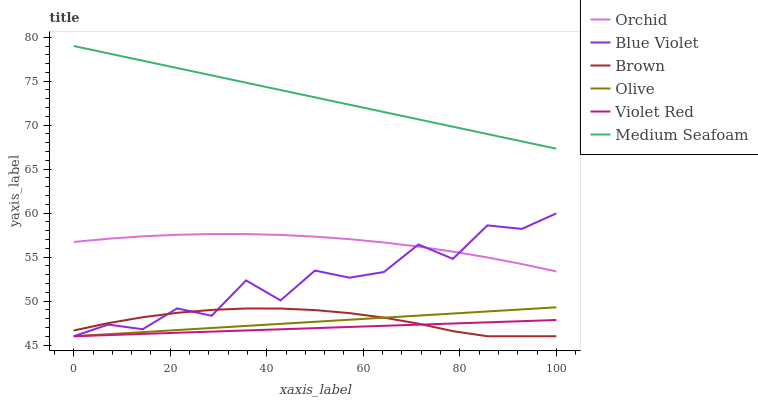Does Violet Red have the minimum area under the curve?
Answer yes or no. Yes. Does Medium Seafoam have the maximum area under the curve?
Answer yes or no. Yes. Does Olive have the minimum area under the curve?
Answer yes or no. No. Does Olive have the maximum area under the curve?
Answer yes or no. No. Is Violet Red the smoothest?
Answer yes or no. Yes. Is Blue Violet the roughest?
Answer yes or no. Yes. Is Olive the smoothest?
Answer yes or no. No. Is Olive the roughest?
Answer yes or no. No. Does Brown have the lowest value?
Answer yes or no. Yes. Does Medium Seafoam have the lowest value?
Answer yes or no. No. Does Medium Seafoam have the highest value?
Answer yes or no. Yes. Does Olive have the highest value?
Answer yes or no. No. Is Olive less than Orchid?
Answer yes or no. Yes. Is Medium Seafoam greater than Blue Violet?
Answer yes or no. Yes. Does Olive intersect Blue Violet?
Answer yes or no. Yes. Is Olive less than Blue Violet?
Answer yes or no. No. Is Olive greater than Blue Violet?
Answer yes or no. No. Does Olive intersect Orchid?
Answer yes or no. No. 